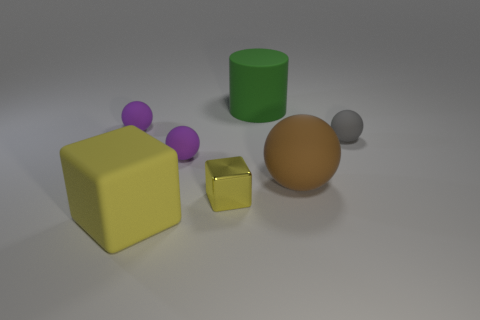Subtract all tiny balls. How many balls are left? 1 Add 2 rubber objects. How many objects exist? 9 Subtract all brown balls. How many balls are left? 3 Subtract all cyan cubes. Subtract all brown balls. How many cubes are left? 2 Subtract all cyan cylinders. How many brown blocks are left? 0 Subtract all tiny gray metallic cylinders. Subtract all big rubber spheres. How many objects are left? 6 Add 3 yellow objects. How many yellow objects are left? 5 Add 2 small purple rubber things. How many small purple rubber things exist? 4 Subtract 0 purple cylinders. How many objects are left? 7 Subtract all cylinders. How many objects are left? 6 